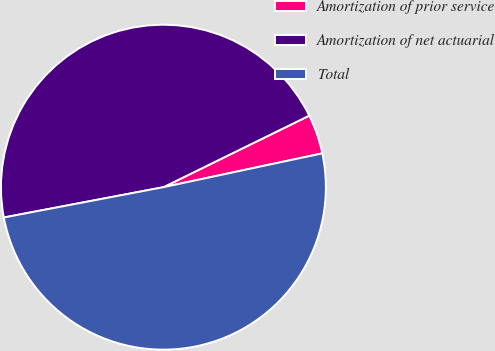<chart> <loc_0><loc_0><loc_500><loc_500><pie_chart><fcel>Amortization of prior service<fcel>Amortization of net actuarial<fcel>Total<nl><fcel>3.92%<fcel>45.73%<fcel>50.35%<nl></chart> 